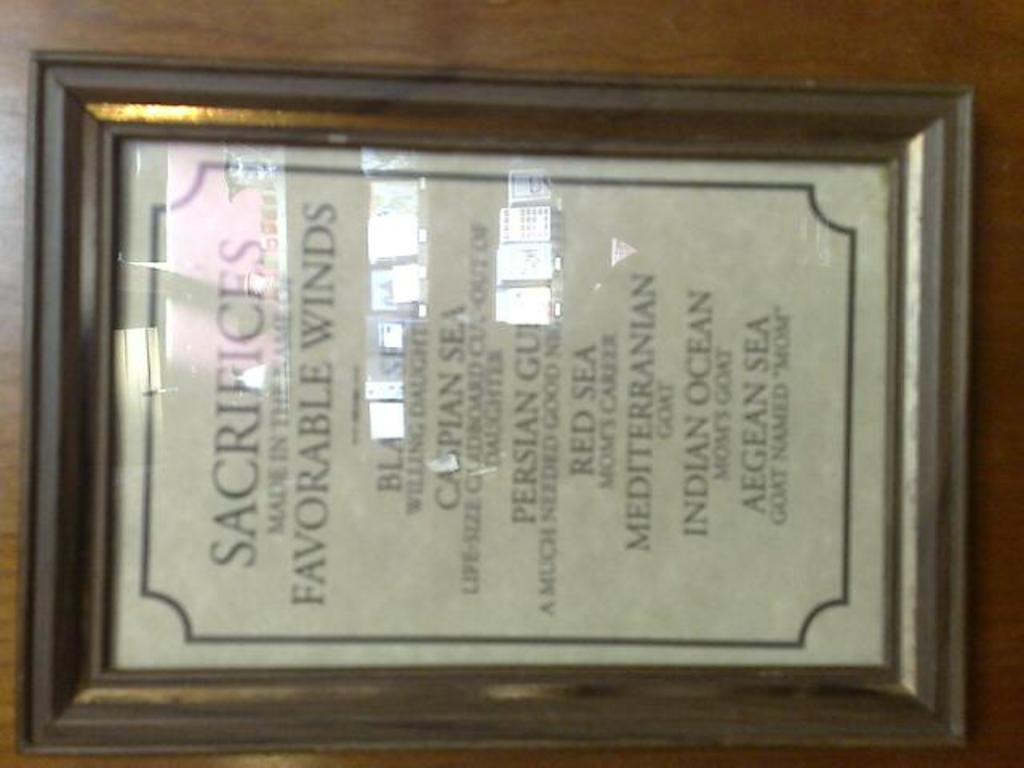<image>
Describe the image concisely. A framed poem lists the oceans of one part of the world. 